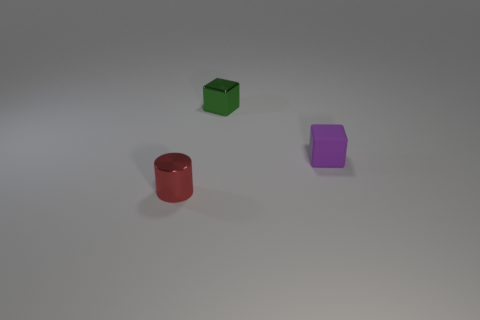Is there any other thing that has the same material as the purple block?
Provide a short and direct response. No. Does the tiny object to the left of the small green object have the same material as the tiny green cube?
Offer a very short reply. Yes. What number of other tiny red shiny things are the same shape as the red shiny thing?
Your answer should be compact. 0. How many big objects are green balls or green shiny things?
Provide a succinct answer. 0. There is a tiny metallic thing that is to the right of the small red object; does it have the same color as the tiny metal cylinder?
Ensure brevity in your answer.  No. Is the color of the cube that is in front of the tiny green thing the same as the metal object that is behind the small purple block?
Offer a terse response. No. Are there any tiny purple cubes that have the same material as the red object?
Give a very brief answer. No. What number of purple things are either cylinders or matte objects?
Make the answer very short. 1. Is the number of small shiny cubes to the right of the small green object greater than the number of tiny purple objects?
Keep it short and to the point. No. Is the metal cylinder the same size as the rubber thing?
Your response must be concise. Yes. 